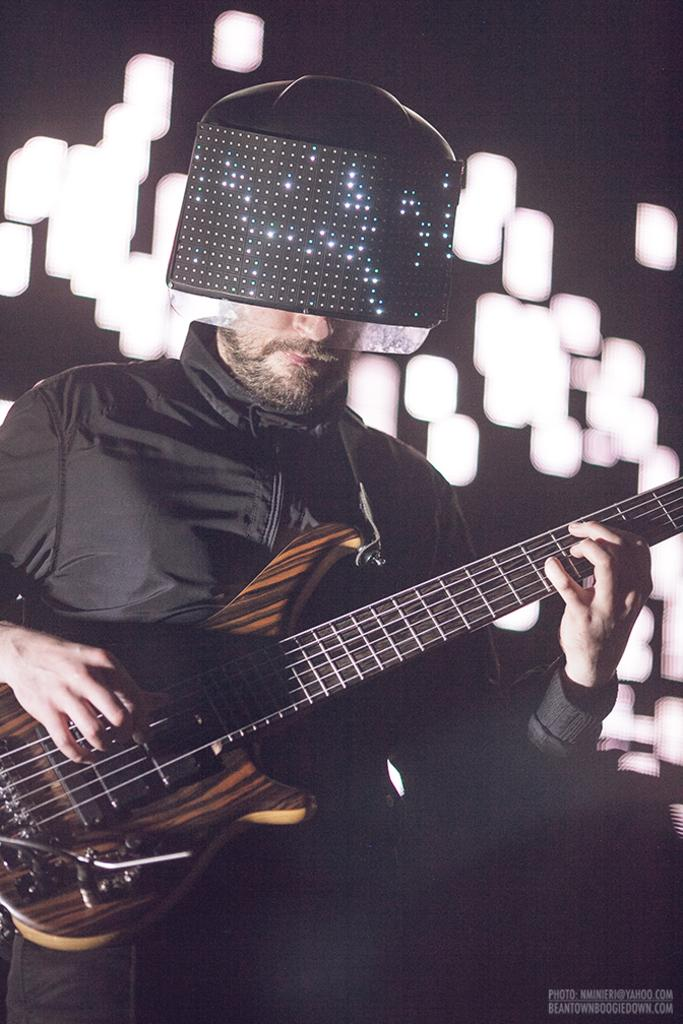What is the main subject of the image? There is a person in the image. What is the person wearing? The person is wearing a helmet. What is the person holding? The person is holding a guitar. What can be seen in the background of the image? There are lights visible in the background of the image. What type of bed can be seen in the image? There is no bed present in the image. What sign is the person holding in the image? The person is not holding a sign in the image; they are holding a guitar. 